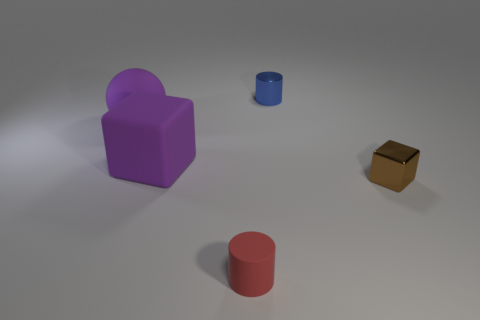There is a object that is the same size as the purple rubber cube; what is its shape? The object that matches the size of the purple rubber cube is a red cylinder. It shares similar dimensions but differs in shape, having a circular base and curved surface. 